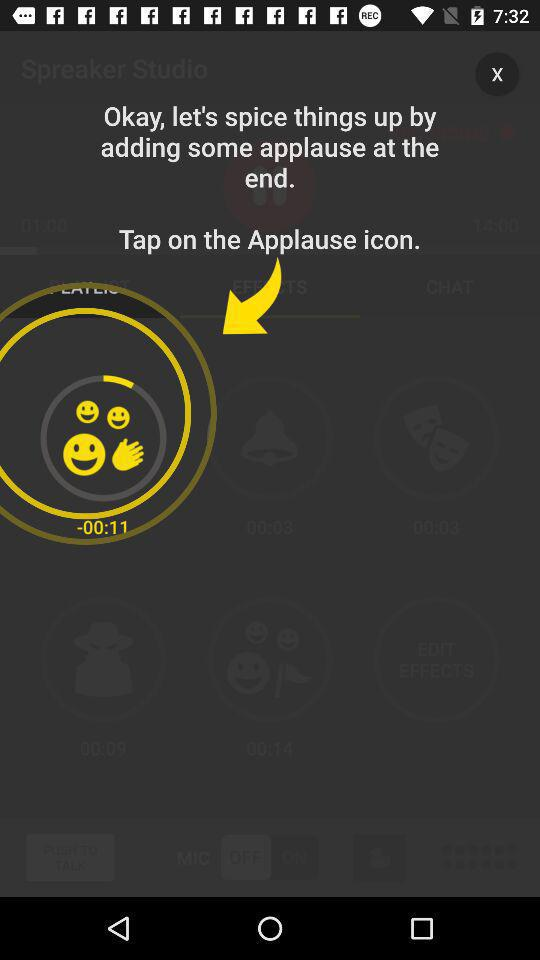What is the name of the user? The name of the user is John Smith. 